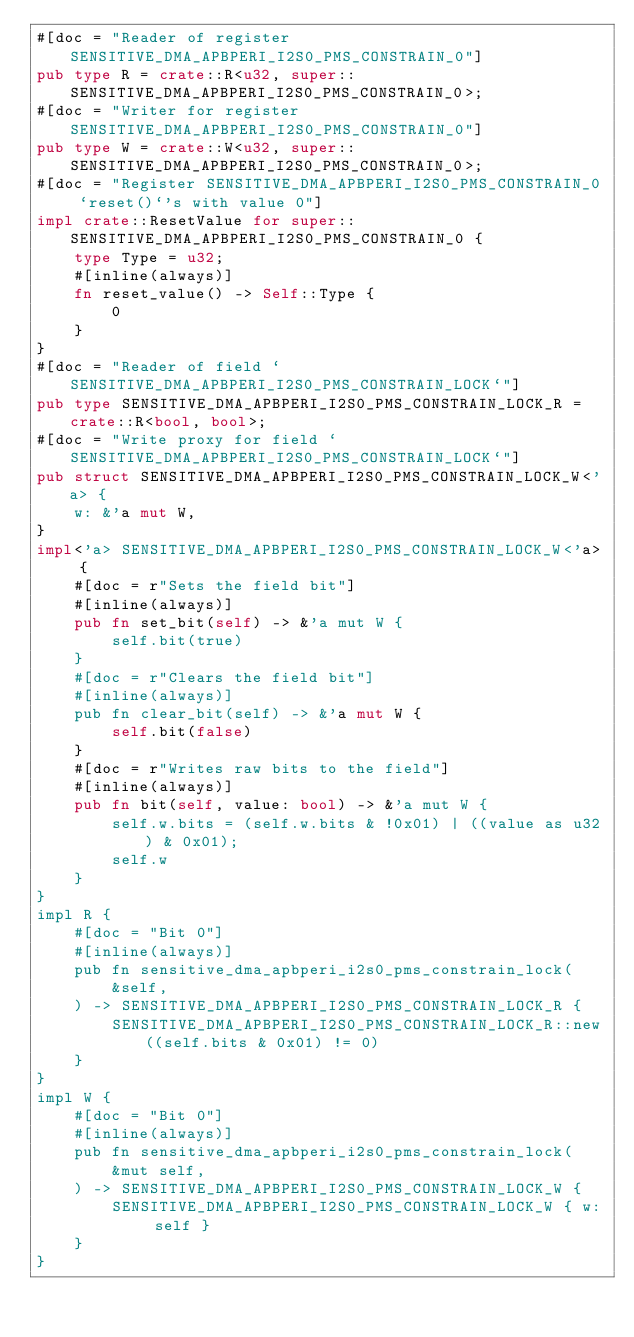Convert code to text. <code><loc_0><loc_0><loc_500><loc_500><_Rust_>#[doc = "Reader of register SENSITIVE_DMA_APBPERI_I2S0_PMS_CONSTRAIN_0"]
pub type R = crate::R<u32, super::SENSITIVE_DMA_APBPERI_I2S0_PMS_CONSTRAIN_0>;
#[doc = "Writer for register SENSITIVE_DMA_APBPERI_I2S0_PMS_CONSTRAIN_0"]
pub type W = crate::W<u32, super::SENSITIVE_DMA_APBPERI_I2S0_PMS_CONSTRAIN_0>;
#[doc = "Register SENSITIVE_DMA_APBPERI_I2S0_PMS_CONSTRAIN_0 `reset()`'s with value 0"]
impl crate::ResetValue for super::SENSITIVE_DMA_APBPERI_I2S0_PMS_CONSTRAIN_0 {
    type Type = u32;
    #[inline(always)]
    fn reset_value() -> Self::Type {
        0
    }
}
#[doc = "Reader of field `SENSITIVE_DMA_APBPERI_I2S0_PMS_CONSTRAIN_LOCK`"]
pub type SENSITIVE_DMA_APBPERI_I2S0_PMS_CONSTRAIN_LOCK_R = crate::R<bool, bool>;
#[doc = "Write proxy for field `SENSITIVE_DMA_APBPERI_I2S0_PMS_CONSTRAIN_LOCK`"]
pub struct SENSITIVE_DMA_APBPERI_I2S0_PMS_CONSTRAIN_LOCK_W<'a> {
    w: &'a mut W,
}
impl<'a> SENSITIVE_DMA_APBPERI_I2S0_PMS_CONSTRAIN_LOCK_W<'a> {
    #[doc = r"Sets the field bit"]
    #[inline(always)]
    pub fn set_bit(self) -> &'a mut W {
        self.bit(true)
    }
    #[doc = r"Clears the field bit"]
    #[inline(always)]
    pub fn clear_bit(self) -> &'a mut W {
        self.bit(false)
    }
    #[doc = r"Writes raw bits to the field"]
    #[inline(always)]
    pub fn bit(self, value: bool) -> &'a mut W {
        self.w.bits = (self.w.bits & !0x01) | ((value as u32) & 0x01);
        self.w
    }
}
impl R {
    #[doc = "Bit 0"]
    #[inline(always)]
    pub fn sensitive_dma_apbperi_i2s0_pms_constrain_lock(
        &self,
    ) -> SENSITIVE_DMA_APBPERI_I2S0_PMS_CONSTRAIN_LOCK_R {
        SENSITIVE_DMA_APBPERI_I2S0_PMS_CONSTRAIN_LOCK_R::new((self.bits & 0x01) != 0)
    }
}
impl W {
    #[doc = "Bit 0"]
    #[inline(always)]
    pub fn sensitive_dma_apbperi_i2s0_pms_constrain_lock(
        &mut self,
    ) -> SENSITIVE_DMA_APBPERI_I2S0_PMS_CONSTRAIN_LOCK_W {
        SENSITIVE_DMA_APBPERI_I2S0_PMS_CONSTRAIN_LOCK_W { w: self }
    }
}
</code> 